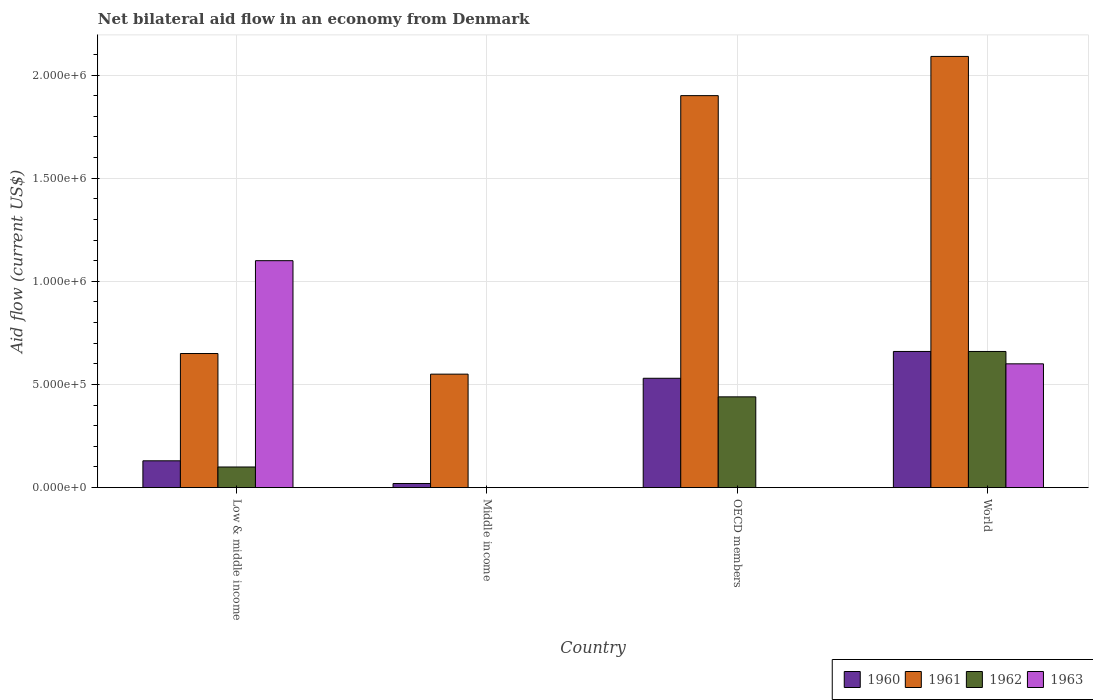How many different coloured bars are there?
Make the answer very short. 4. Are the number of bars on each tick of the X-axis equal?
Ensure brevity in your answer.  No. What is the label of the 4th group of bars from the left?
Keep it short and to the point. World. In how many cases, is the number of bars for a given country not equal to the number of legend labels?
Offer a terse response. 2. What is the net bilateral aid flow in 1960 in Low & middle income?
Provide a succinct answer. 1.30e+05. Across all countries, what is the maximum net bilateral aid flow in 1962?
Give a very brief answer. 6.60e+05. What is the total net bilateral aid flow in 1963 in the graph?
Provide a succinct answer. 1.70e+06. What is the difference between the net bilateral aid flow in 1962 in OECD members and that in World?
Provide a succinct answer. -2.20e+05. What is the difference between the net bilateral aid flow of/in 1960 and net bilateral aid flow of/in 1961 in Middle income?
Ensure brevity in your answer.  -5.30e+05. In how many countries, is the net bilateral aid flow in 1963 greater than 1300000 US$?
Your response must be concise. 0. What is the ratio of the net bilateral aid flow in 1960 in OECD members to that in World?
Offer a very short reply. 0.8. Is the net bilateral aid flow in 1960 in Middle income less than that in OECD members?
Provide a succinct answer. Yes. What is the difference between the highest and the second highest net bilateral aid flow in 1962?
Make the answer very short. 5.60e+05. What is the difference between the highest and the lowest net bilateral aid flow in 1961?
Offer a very short reply. 1.54e+06. In how many countries, is the net bilateral aid flow in 1963 greater than the average net bilateral aid flow in 1963 taken over all countries?
Your answer should be compact. 2. Is it the case that in every country, the sum of the net bilateral aid flow in 1962 and net bilateral aid flow in 1963 is greater than the net bilateral aid flow in 1961?
Offer a terse response. No. Does the graph contain any zero values?
Give a very brief answer. Yes. Where does the legend appear in the graph?
Give a very brief answer. Bottom right. How many legend labels are there?
Give a very brief answer. 4. How are the legend labels stacked?
Offer a terse response. Horizontal. What is the title of the graph?
Keep it short and to the point. Net bilateral aid flow in an economy from Denmark. What is the label or title of the X-axis?
Your response must be concise. Country. What is the Aid flow (current US$) in 1961 in Low & middle income?
Offer a very short reply. 6.50e+05. What is the Aid flow (current US$) in 1962 in Low & middle income?
Provide a short and direct response. 1.00e+05. What is the Aid flow (current US$) in 1963 in Low & middle income?
Make the answer very short. 1.10e+06. What is the Aid flow (current US$) in 1963 in Middle income?
Offer a terse response. 0. What is the Aid flow (current US$) of 1960 in OECD members?
Provide a succinct answer. 5.30e+05. What is the Aid flow (current US$) in 1961 in OECD members?
Offer a terse response. 1.90e+06. What is the Aid flow (current US$) of 1963 in OECD members?
Your answer should be compact. 0. What is the Aid flow (current US$) of 1961 in World?
Your answer should be compact. 2.09e+06. What is the Aid flow (current US$) in 1962 in World?
Offer a terse response. 6.60e+05. What is the Aid flow (current US$) of 1963 in World?
Provide a succinct answer. 6.00e+05. Across all countries, what is the maximum Aid flow (current US$) of 1961?
Provide a succinct answer. 2.09e+06. Across all countries, what is the maximum Aid flow (current US$) of 1963?
Keep it short and to the point. 1.10e+06. Across all countries, what is the minimum Aid flow (current US$) of 1960?
Provide a short and direct response. 2.00e+04. Across all countries, what is the minimum Aid flow (current US$) of 1962?
Your response must be concise. 0. What is the total Aid flow (current US$) in 1960 in the graph?
Your response must be concise. 1.34e+06. What is the total Aid flow (current US$) in 1961 in the graph?
Provide a succinct answer. 5.19e+06. What is the total Aid flow (current US$) of 1962 in the graph?
Make the answer very short. 1.20e+06. What is the total Aid flow (current US$) in 1963 in the graph?
Offer a very short reply. 1.70e+06. What is the difference between the Aid flow (current US$) in 1960 in Low & middle income and that in OECD members?
Your answer should be compact. -4.00e+05. What is the difference between the Aid flow (current US$) of 1961 in Low & middle income and that in OECD members?
Your answer should be compact. -1.25e+06. What is the difference between the Aid flow (current US$) of 1960 in Low & middle income and that in World?
Ensure brevity in your answer.  -5.30e+05. What is the difference between the Aid flow (current US$) in 1961 in Low & middle income and that in World?
Your answer should be very brief. -1.44e+06. What is the difference between the Aid flow (current US$) in 1962 in Low & middle income and that in World?
Provide a succinct answer. -5.60e+05. What is the difference between the Aid flow (current US$) in 1960 in Middle income and that in OECD members?
Make the answer very short. -5.10e+05. What is the difference between the Aid flow (current US$) in 1961 in Middle income and that in OECD members?
Your response must be concise. -1.35e+06. What is the difference between the Aid flow (current US$) of 1960 in Middle income and that in World?
Ensure brevity in your answer.  -6.40e+05. What is the difference between the Aid flow (current US$) in 1961 in Middle income and that in World?
Make the answer very short. -1.54e+06. What is the difference between the Aid flow (current US$) of 1962 in OECD members and that in World?
Your answer should be compact. -2.20e+05. What is the difference between the Aid flow (current US$) in 1960 in Low & middle income and the Aid flow (current US$) in 1961 in Middle income?
Offer a very short reply. -4.20e+05. What is the difference between the Aid flow (current US$) in 1960 in Low & middle income and the Aid flow (current US$) in 1961 in OECD members?
Provide a short and direct response. -1.77e+06. What is the difference between the Aid flow (current US$) of 1960 in Low & middle income and the Aid flow (current US$) of 1962 in OECD members?
Your answer should be compact. -3.10e+05. What is the difference between the Aid flow (current US$) in 1960 in Low & middle income and the Aid flow (current US$) in 1961 in World?
Make the answer very short. -1.96e+06. What is the difference between the Aid flow (current US$) in 1960 in Low & middle income and the Aid flow (current US$) in 1962 in World?
Offer a very short reply. -5.30e+05. What is the difference between the Aid flow (current US$) in 1960 in Low & middle income and the Aid flow (current US$) in 1963 in World?
Your answer should be compact. -4.70e+05. What is the difference between the Aid flow (current US$) in 1961 in Low & middle income and the Aid flow (current US$) in 1962 in World?
Ensure brevity in your answer.  -10000. What is the difference between the Aid flow (current US$) in 1962 in Low & middle income and the Aid flow (current US$) in 1963 in World?
Your answer should be compact. -5.00e+05. What is the difference between the Aid flow (current US$) of 1960 in Middle income and the Aid flow (current US$) of 1961 in OECD members?
Make the answer very short. -1.88e+06. What is the difference between the Aid flow (current US$) in 1960 in Middle income and the Aid flow (current US$) in 1962 in OECD members?
Offer a very short reply. -4.20e+05. What is the difference between the Aid flow (current US$) in 1960 in Middle income and the Aid flow (current US$) in 1961 in World?
Offer a terse response. -2.07e+06. What is the difference between the Aid flow (current US$) in 1960 in Middle income and the Aid flow (current US$) in 1962 in World?
Your answer should be compact. -6.40e+05. What is the difference between the Aid flow (current US$) in 1960 in Middle income and the Aid flow (current US$) in 1963 in World?
Your answer should be very brief. -5.80e+05. What is the difference between the Aid flow (current US$) of 1961 in Middle income and the Aid flow (current US$) of 1962 in World?
Your answer should be compact. -1.10e+05. What is the difference between the Aid flow (current US$) in 1960 in OECD members and the Aid flow (current US$) in 1961 in World?
Your answer should be compact. -1.56e+06. What is the difference between the Aid flow (current US$) in 1960 in OECD members and the Aid flow (current US$) in 1962 in World?
Make the answer very short. -1.30e+05. What is the difference between the Aid flow (current US$) in 1961 in OECD members and the Aid flow (current US$) in 1962 in World?
Provide a short and direct response. 1.24e+06. What is the difference between the Aid flow (current US$) in 1961 in OECD members and the Aid flow (current US$) in 1963 in World?
Offer a terse response. 1.30e+06. What is the difference between the Aid flow (current US$) of 1962 in OECD members and the Aid flow (current US$) of 1963 in World?
Give a very brief answer. -1.60e+05. What is the average Aid flow (current US$) in 1960 per country?
Provide a succinct answer. 3.35e+05. What is the average Aid flow (current US$) in 1961 per country?
Keep it short and to the point. 1.30e+06. What is the average Aid flow (current US$) of 1962 per country?
Your response must be concise. 3.00e+05. What is the average Aid flow (current US$) in 1963 per country?
Your answer should be compact. 4.25e+05. What is the difference between the Aid flow (current US$) in 1960 and Aid flow (current US$) in 1961 in Low & middle income?
Keep it short and to the point. -5.20e+05. What is the difference between the Aid flow (current US$) in 1960 and Aid flow (current US$) in 1963 in Low & middle income?
Your answer should be compact. -9.70e+05. What is the difference between the Aid flow (current US$) of 1961 and Aid flow (current US$) of 1962 in Low & middle income?
Ensure brevity in your answer.  5.50e+05. What is the difference between the Aid flow (current US$) of 1961 and Aid flow (current US$) of 1963 in Low & middle income?
Provide a short and direct response. -4.50e+05. What is the difference between the Aid flow (current US$) in 1962 and Aid flow (current US$) in 1963 in Low & middle income?
Give a very brief answer. -1.00e+06. What is the difference between the Aid flow (current US$) in 1960 and Aid flow (current US$) in 1961 in Middle income?
Offer a terse response. -5.30e+05. What is the difference between the Aid flow (current US$) of 1960 and Aid flow (current US$) of 1961 in OECD members?
Your answer should be compact. -1.37e+06. What is the difference between the Aid flow (current US$) in 1960 and Aid flow (current US$) in 1962 in OECD members?
Offer a terse response. 9.00e+04. What is the difference between the Aid flow (current US$) in 1961 and Aid flow (current US$) in 1962 in OECD members?
Give a very brief answer. 1.46e+06. What is the difference between the Aid flow (current US$) in 1960 and Aid flow (current US$) in 1961 in World?
Make the answer very short. -1.43e+06. What is the difference between the Aid flow (current US$) of 1961 and Aid flow (current US$) of 1962 in World?
Your answer should be very brief. 1.43e+06. What is the difference between the Aid flow (current US$) of 1961 and Aid flow (current US$) of 1963 in World?
Provide a short and direct response. 1.49e+06. What is the difference between the Aid flow (current US$) of 1962 and Aid flow (current US$) of 1963 in World?
Your answer should be very brief. 6.00e+04. What is the ratio of the Aid flow (current US$) of 1961 in Low & middle income to that in Middle income?
Give a very brief answer. 1.18. What is the ratio of the Aid flow (current US$) in 1960 in Low & middle income to that in OECD members?
Ensure brevity in your answer.  0.25. What is the ratio of the Aid flow (current US$) in 1961 in Low & middle income to that in OECD members?
Ensure brevity in your answer.  0.34. What is the ratio of the Aid flow (current US$) of 1962 in Low & middle income to that in OECD members?
Provide a short and direct response. 0.23. What is the ratio of the Aid flow (current US$) in 1960 in Low & middle income to that in World?
Your answer should be compact. 0.2. What is the ratio of the Aid flow (current US$) of 1961 in Low & middle income to that in World?
Give a very brief answer. 0.31. What is the ratio of the Aid flow (current US$) in 1962 in Low & middle income to that in World?
Offer a very short reply. 0.15. What is the ratio of the Aid flow (current US$) of 1963 in Low & middle income to that in World?
Offer a very short reply. 1.83. What is the ratio of the Aid flow (current US$) in 1960 in Middle income to that in OECD members?
Keep it short and to the point. 0.04. What is the ratio of the Aid flow (current US$) in 1961 in Middle income to that in OECD members?
Ensure brevity in your answer.  0.29. What is the ratio of the Aid flow (current US$) in 1960 in Middle income to that in World?
Ensure brevity in your answer.  0.03. What is the ratio of the Aid flow (current US$) of 1961 in Middle income to that in World?
Your response must be concise. 0.26. What is the ratio of the Aid flow (current US$) of 1960 in OECD members to that in World?
Give a very brief answer. 0.8. What is the difference between the highest and the second highest Aid flow (current US$) of 1961?
Ensure brevity in your answer.  1.90e+05. What is the difference between the highest and the lowest Aid flow (current US$) of 1960?
Ensure brevity in your answer.  6.40e+05. What is the difference between the highest and the lowest Aid flow (current US$) of 1961?
Keep it short and to the point. 1.54e+06. What is the difference between the highest and the lowest Aid flow (current US$) in 1962?
Offer a terse response. 6.60e+05. What is the difference between the highest and the lowest Aid flow (current US$) in 1963?
Your answer should be compact. 1.10e+06. 